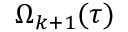<formula> <loc_0><loc_0><loc_500><loc_500>\Omega _ { k + 1 } ( \tau )</formula> 